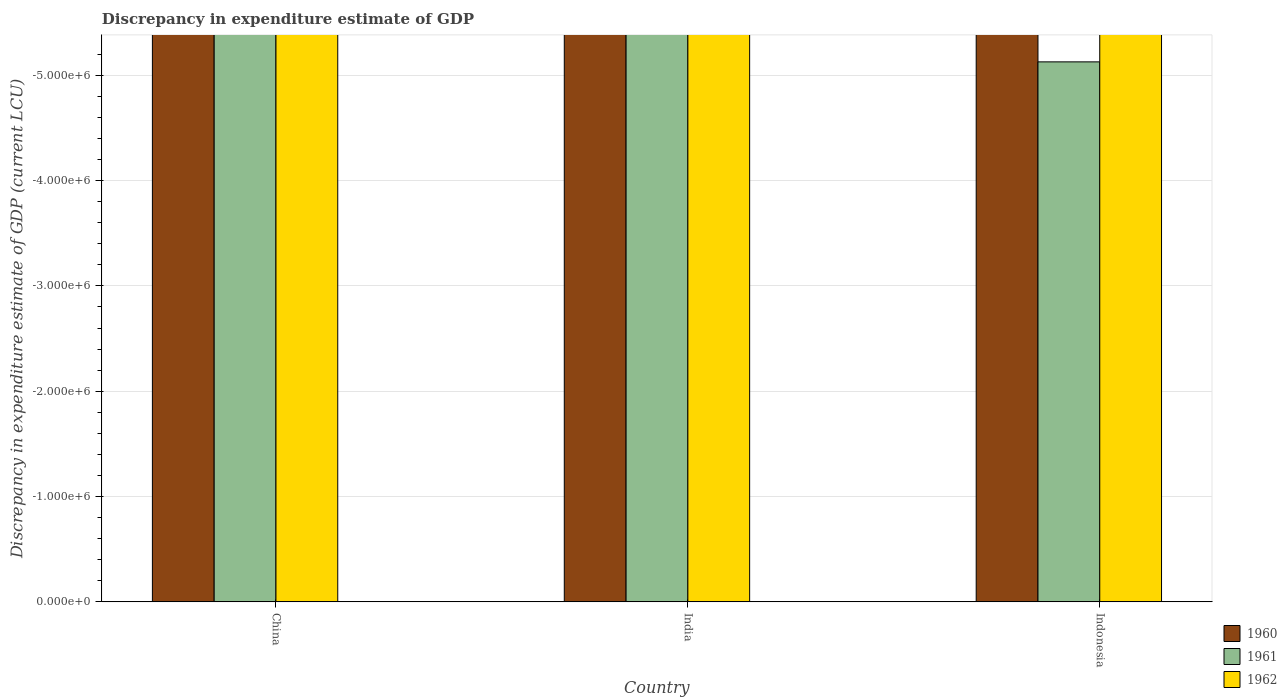How many different coloured bars are there?
Ensure brevity in your answer.  0. Are the number of bars per tick equal to the number of legend labels?
Offer a terse response. No. How many bars are there on the 2nd tick from the left?
Make the answer very short. 0. What is the label of the 2nd group of bars from the left?
Provide a succinct answer. India. Across all countries, what is the minimum discrepancy in expenditure estimate of GDP in 1960?
Provide a succinct answer. 0. What is the difference between the discrepancy in expenditure estimate of GDP in 1961 in India and the discrepancy in expenditure estimate of GDP in 1962 in Indonesia?
Your answer should be compact. 0. What is the average discrepancy in expenditure estimate of GDP in 1960 per country?
Give a very brief answer. 0. How many bars are there?
Your answer should be compact. 0. Are all the bars in the graph horizontal?
Offer a very short reply. No. Are the values on the major ticks of Y-axis written in scientific E-notation?
Make the answer very short. Yes. Does the graph contain grids?
Keep it short and to the point. Yes. How many legend labels are there?
Your response must be concise. 3. How are the legend labels stacked?
Make the answer very short. Vertical. What is the title of the graph?
Your answer should be compact. Discrepancy in expenditure estimate of GDP. Does "1977" appear as one of the legend labels in the graph?
Your answer should be very brief. No. What is the label or title of the X-axis?
Offer a terse response. Country. What is the label or title of the Y-axis?
Your answer should be very brief. Discrepancy in expenditure estimate of GDP (current LCU). What is the Discrepancy in expenditure estimate of GDP (current LCU) in 1962 in China?
Ensure brevity in your answer.  0. What is the Discrepancy in expenditure estimate of GDP (current LCU) in 1960 in India?
Give a very brief answer. 0. What is the Discrepancy in expenditure estimate of GDP (current LCU) of 1962 in India?
Offer a terse response. 0. What is the Discrepancy in expenditure estimate of GDP (current LCU) in 1960 in Indonesia?
Your response must be concise. 0. What is the Discrepancy in expenditure estimate of GDP (current LCU) of 1961 in Indonesia?
Your answer should be very brief. 0. What is the Discrepancy in expenditure estimate of GDP (current LCU) in 1962 in Indonesia?
Offer a very short reply. 0. What is the total Discrepancy in expenditure estimate of GDP (current LCU) in 1960 in the graph?
Provide a short and direct response. 0. What is the total Discrepancy in expenditure estimate of GDP (current LCU) of 1961 in the graph?
Provide a short and direct response. 0. What is the average Discrepancy in expenditure estimate of GDP (current LCU) in 1960 per country?
Keep it short and to the point. 0. What is the average Discrepancy in expenditure estimate of GDP (current LCU) in 1962 per country?
Offer a very short reply. 0. 